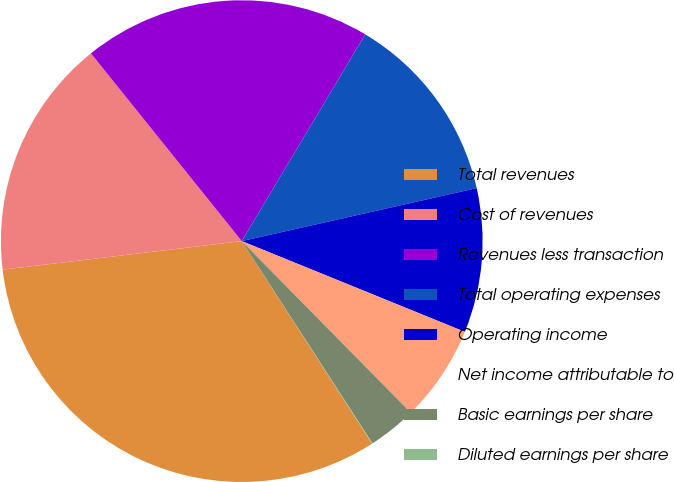Convert chart to OTSL. <chart><loc_0><loc_0><loc_500><loc_500><pie_chart><fcel>Total revenues<fcel>Cost of revenues<fcel>Revenues less transaction<fcel>Total operating expenses<fcel>Operating income<fcel>Net income attributable to<fcel>Basic earnings per share<fcel>Diluted earnings per share<nl><fcel>32.21%<fcel>16.12%<fcel>19.34%<fcel>12.9%<fcel>9.68%<fcel>6.47%<fcel>3.25%<fcel>0.03%<nl></chart> 